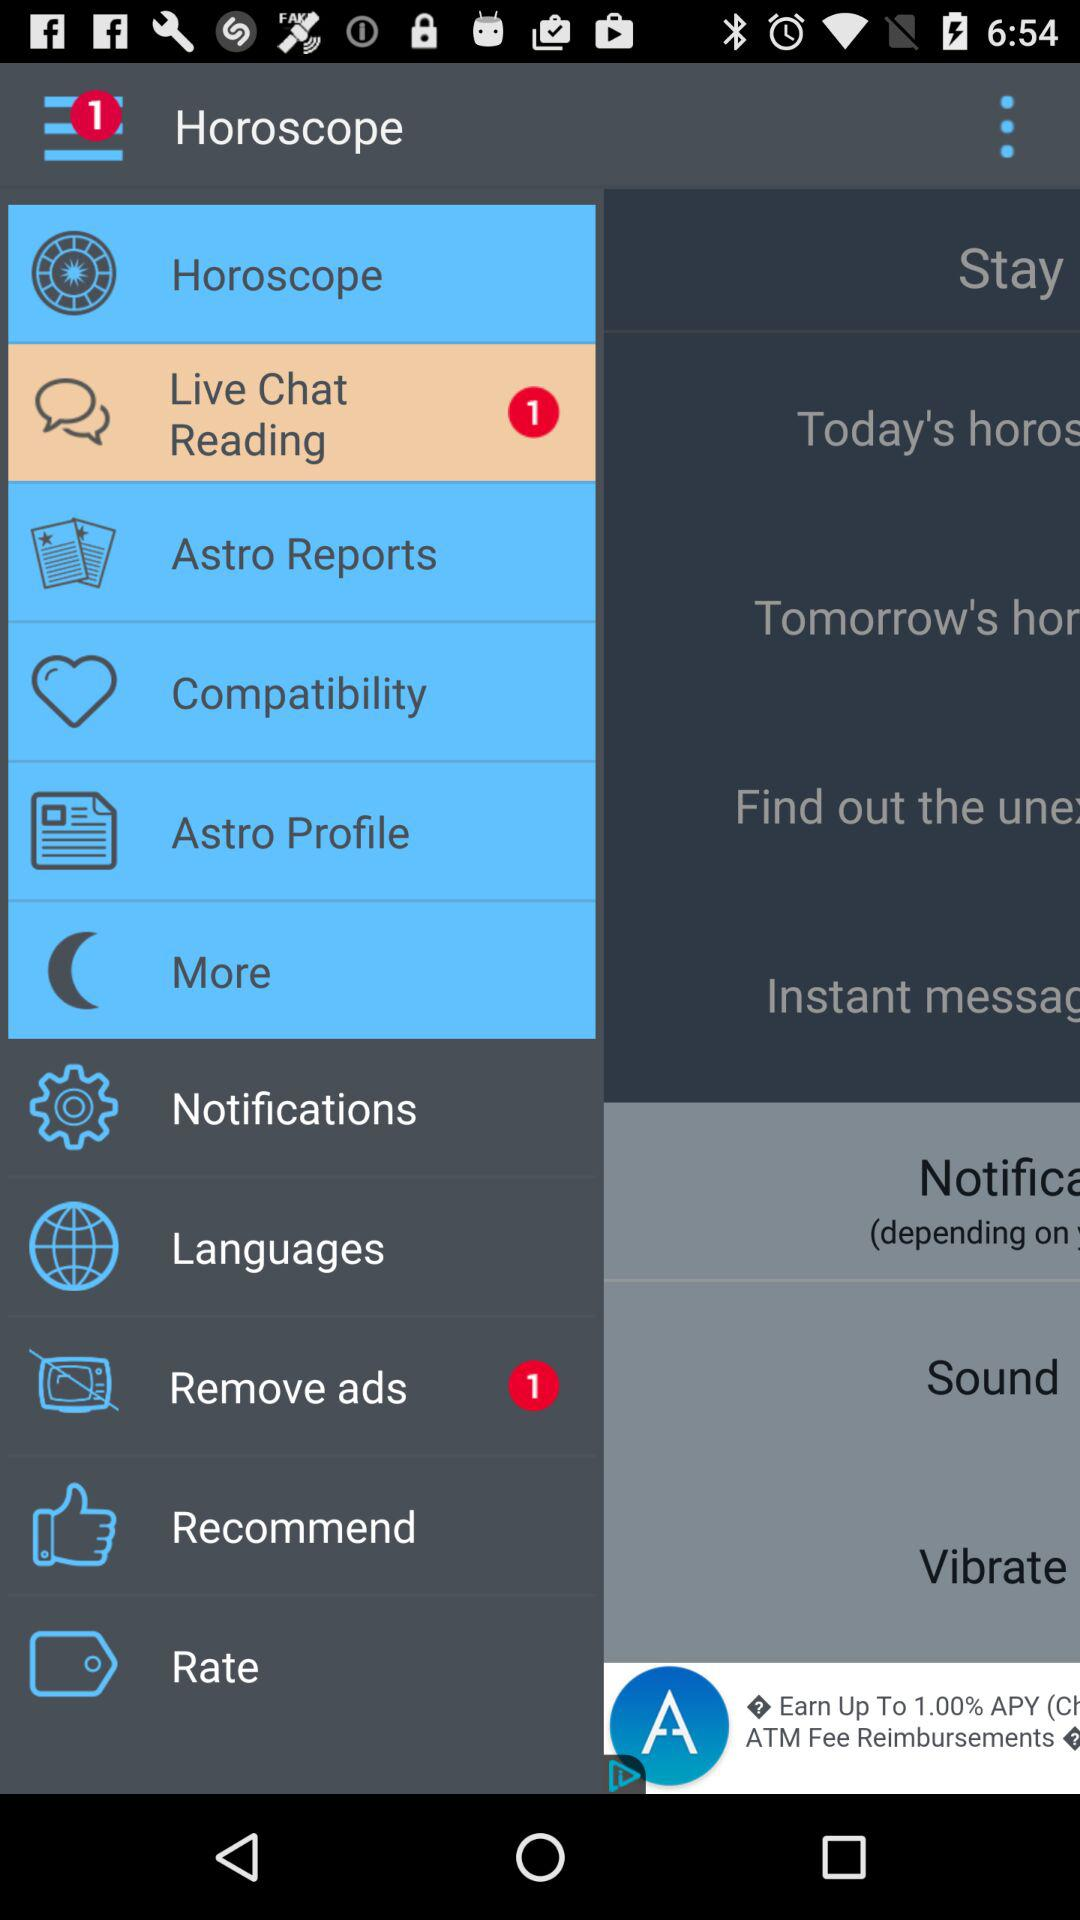How many notifications are there in "Remove ads"? There is 1 notification. 